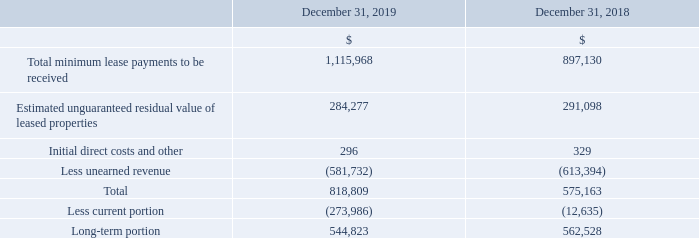Net Investment in Direct Financing Leases and Sales-Type Leases
Teekay LNG owns a 70% ownership interest in Teekay BLT Corporation (or the Teekay Tangguh Joint Venture), which is a party to operating leases whereby the Teekay Tangguh Joint Venture leases two LNG carriers (or the Tangguh LNG Carriers) to a third party, which in turn leases the vessels back to the joint venture. The time charters for the two Tangguh LNG carriers are accounted for as direct financing leases. The Tangguh LNG Carriers commenced their time charters with their charterers in 2009.
In 2013, Teekay LNG acquired two 155,900-cubic meter LNG carriers, the WilPride and WilForce, from Norway-based Awilco LNG ASA (or Awilco) and chartered them back to Awilco on five- and four-year fixed-rate bareboat charter contracts (plus a one-year extension option), respectively, with Awilco holding a fixed-price purchase obligation at the end of the charters. The bareboat charters with Awilco were accounted for as direct financing leases.
However, in June 2017, Teekay LNG agreed to amend the charter contracts with Awilco to defer a portion of charter hire and extend the bareboat charter contracts and related purchase obligations on both vessels to December 2019. The amendments had the effect of deferring charter hire of between $10,600 per day and $20,600 per day per vessel from July 1, 2017 until December 2019, with such deferred amounts added to the purchase obligation amounts.
As a result of the contract amendments, both of the charter contracts with Awilco were reclassified as operating leases upon the expiry of their respective original contract terms in November 2017 and August 2018.
In September 2019, Awilco exercised its option to extend both charters from December 31, 2019 by up to 60 days with the ownership of both vessels transferring to Awilco at the end of this extension. In October 2019, Awilco obtained credit approval for a financing facility that would provide funds necessary for Awilco to satisfy its purchase obligation of the two LNG carriers.
As a result, both vessels were derecognized from the consolidated balance sheets and sales-type lease receivables were recognized based on the remaining amounts owing to Teekay LNG, including the purchase obligations. Teekay LNG recognized a gain of $14.3 million upon derecognition of the vessels for the year ended December 31, 2019, which was included in write-down and loss on sale of vessels in the Company's consolidated statements of loss (see Note 19). Awilco purchased both vessels in January 2020 (see Note 24(a)).
In addition, the 21-year charter contract for the Bahrain Spirit floating storage unit (or FSU) commenced in September 2018 and is accounted for as a direct finance lease. The following table lists the components of the net investments in direct financing leases and sales-type leases:
As at December 31, 2019, estimated minimum lease payments to be received by Teekay LNG related to its direct financing and sales-type leases in each of the next five succeeding fiscal years were approximately $324.7 million (2020), $64.2 million (2021), $64.2 million (2022), $64.0 million (2023), $64.3 million (2024) and an aggregate of $534.6 million thereafter. The leases are scheduled to end between 2020 and 2039.
As at December 31, 2018, estimated minimum lease payments to be received by Teekay LNG related to its direct financing leases in each of the next five years were approximately $63.9 million (2019), $64.3 million (2020), $64.2 million (2021), $64.2 million (2022), $64.0 million (2023) and an aggregate of $576.5 million thereafter.
What was the impact on Teekay LNG on derecognition of the vessels for the year ended December 31, 2019? Teekay lng recognized a gain of $14.3 million upon derecognition of the vessels for the year ended december 31, 2019, which was included in write-down and loss on sale of vessels in the company's consolidated statements of loss. As at December 31, 2019 what was the minimum lease payments to be received by Teekay LNG related to its direct financing and sales-type leases in 2020? As at december 31, 2019, estimated minimum lease payments to be received by teekay lng related to its direct financing and sales-type leases in each of the next five succeeding fiscal years were approximately $324.7 million (2020). As at December 31, 2018 what was the minimum lease payments to be received by Teekay LNG related to its direct financing leases in 2019? As at december 31, 2018, estimated minimum lease payments to be received by teekay lng related to its direct financing leases in each of the next five years were approximately $63.9 million (2019). What is the increase/ (decrease) in Total minimum lease payments to be received from December 31, 2019 to December 31, 2018?
Answer scale should be: million. 1,115,968-897,130
Answer: 218838. What is the increase/ (decrease) in Estimated unguaranteed residual value of leased properties from December 31, 2019 to December 31, 2018?
Answer scale should be: million. 284,277-291,098
Answer: -6821. What is the increase/ (decrease) in Initial direct costs and other from December 31, 2019 to December 31, 2018?
Answer scale should be: million. 296-329
Answer: -33. 